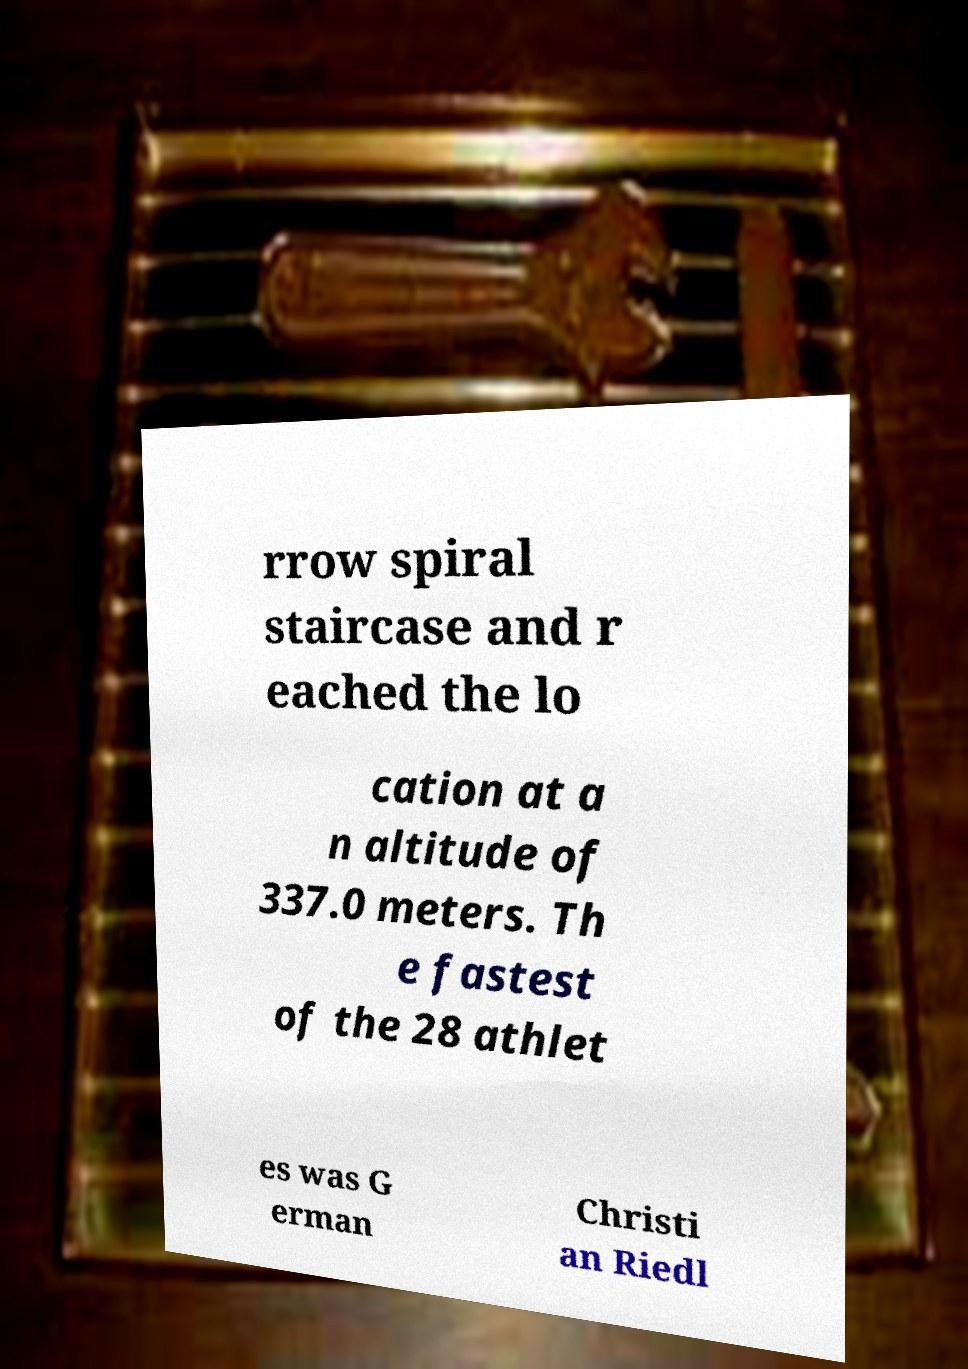I need the written content from this picture converted into text. Can you do that? rrow spiral staircase and r eached the lo cation at a n altitude of 337.0 meters. Th e fastest of the 28 athlet es was G erman Christi an Riedl 